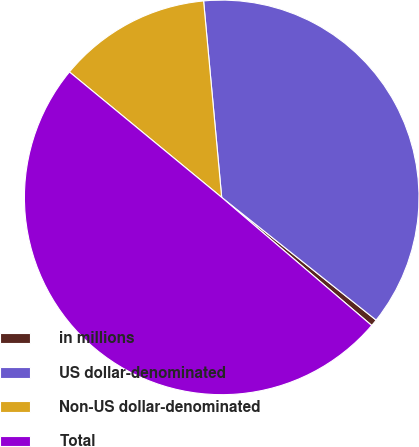Convert chart to OTSL. <chart><loc_0><loc_0><loc_500><loc_500><pie_chart><fcel>in millions<fcel>US dollar-denominated<fcel>Non-US dollar-denominated<fcel>Total<nl><fcel>0.56%<fcel>37.15%<fcel>12.57%<fcel>49.72%<nl></chart> 